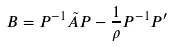Convert formula to latex. <formula><loc_0><loc_0><loc_500><loc_500>B = P ^ { - 1 } { \tilde { A } } P - \frac { 1 } { \rho } P ^ { - 1 } P ^ { \prime }</formula> 